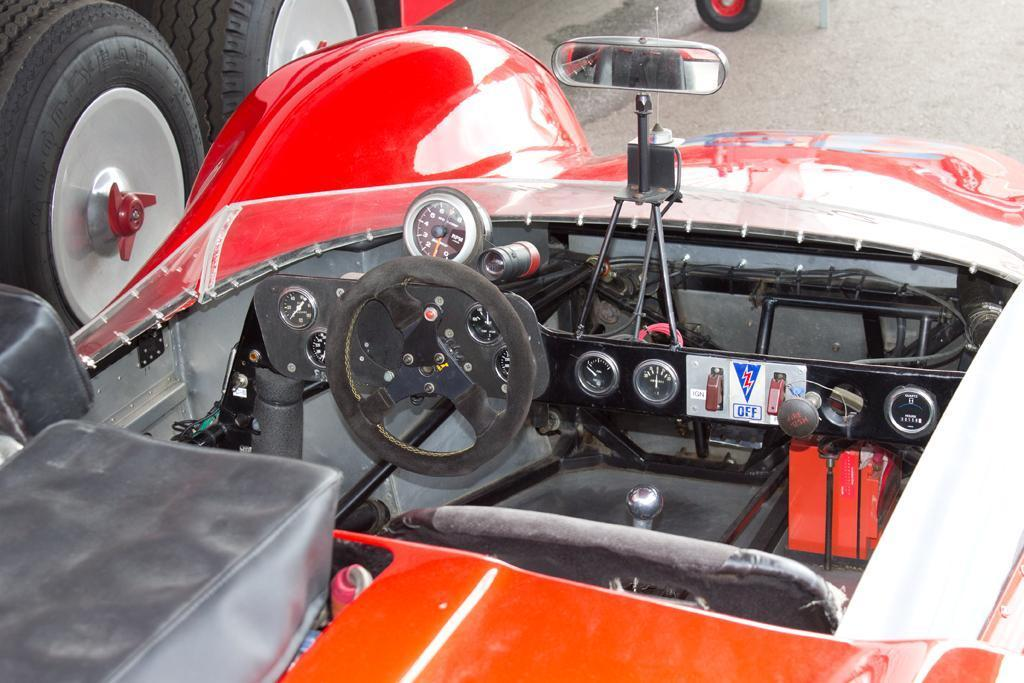What type of vehicle is in the image? There is a vehicle in the image, but the specific type is not mentioned. What feature is present in the vehicle for controlling its direction? The vehicle has a steering wheel for controlling its direction. What instruments are present in the vehicle for monitoring its status? The vehicle has meters for monitoring its status. What feature is present in the vehicle for the driver to see behind them? The vehicle has a mirror for the driver to see behind them. What feature is present in the vehicle to support it when not in motion? The vehicle has a stand to support it when not in motion. What part of the vehicle allows it to move on a surface? The vehicle has tires for moving on a surface. What type of surface is visible at the top of the image? There is a road visible at the top of the image. Can you tell me how many books are in the library in the image? There is no library present in the image; it features a vehicle with various features and a road visible at the top. 